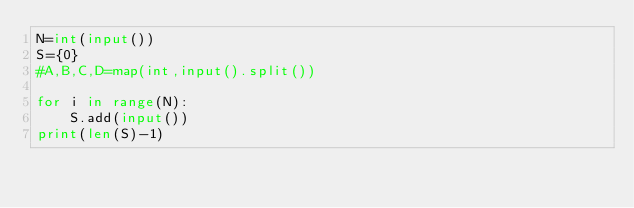<code> <loc_0><loc_0><loc_500><loc_500><_Python_>N=int(input())
S={0}
#A,B,C,D=map(int,input().split())

for i in range(N):
	S.add(input())
print(len(S)-1)</code> 